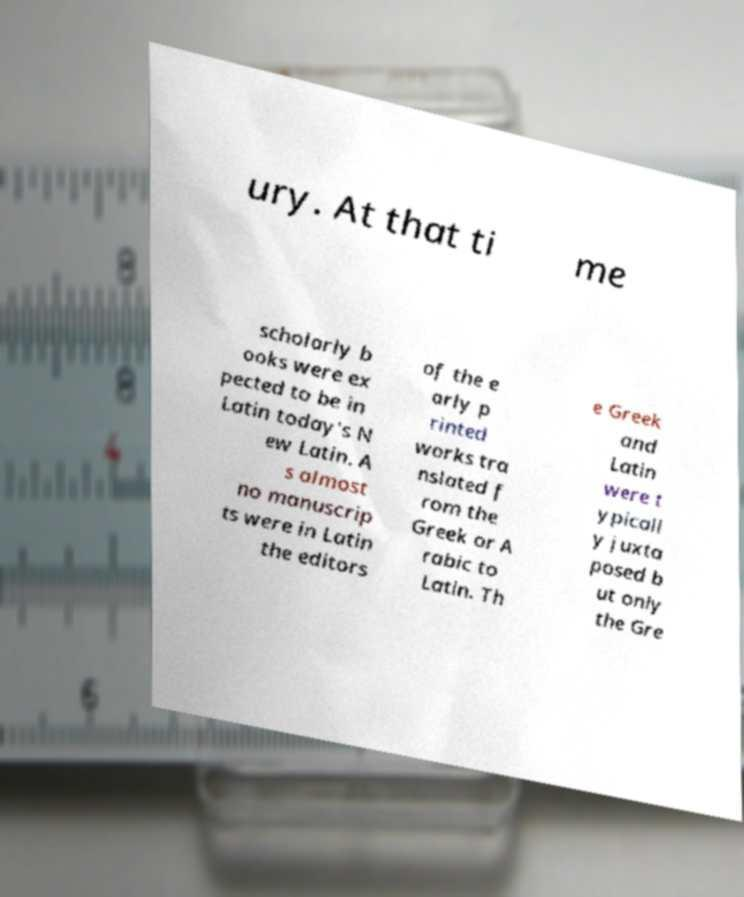For documentation purposes, I need the text within this image transcribed. Could you provide that? ury. At that ti me scholarly b ooks were ex pected to be in Latin today's N ew Latin. A s almost no manuscrip ts were in Latin the editors of the e arly p rinted works tra nslated f rom the Greek or A rabic to Latin. Th e Greek and Latin were t ypicall y juxta posed b ut only the Gre 